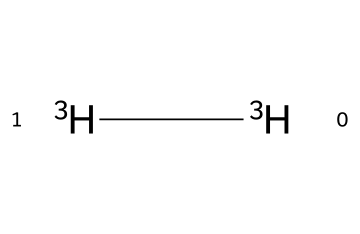How many hydrogen atoms are present in this structure? The SMILES representation indicates two instances of the isotope tritium, which is a hydrogen isotope. Each instance of "[3H]" represents one hydrogen atom. Thus, there are 2 hydrogen atoms in total.
Answer: 2 What is the primary use of tritium in context of this chemical structure? The structure represents tritium, which is commonly used in self-illuminating watch dials. The isotope’s radioactive properties allow it to glow in the dark, making it suitable for this application.
Answer: self-illuminating watch dials How many neutrons does tritium have? Tritium (symbol 3H) has 2 neutrons, as it is a hydrogen isotope with an atomic mass of 3 (1 proton + 2 neutrons). The neutrons can be calculated by subtracting the number of protons (1) from the atomic mass (3).
Answer: 2 What type of isotope is represented in this chemical? The structure depicts the isotope tritium, which is classified as a radioactive isotope of hydrogen. This classification is based on its unstable nucleus, which results in radioactive decay.
Answer: radioactive Which isotopes can be found in the same group as tritium? Tritium is in the same group as deuterium and protium, which are both isotopes of hydrogen. They differ in the number of neutrons present in their nuclei; deuterium has 1 neutron, and protium has none.
Answer: deuterium and protium What is the atomic symbol for tritium? The atomic symbol for tritium is 3H, which clearly denotes that it is a hydrogen isotope with a mass number of 3. The "3" represents the total number of protons and neutrons in the nucleus.
Answer: 3H 